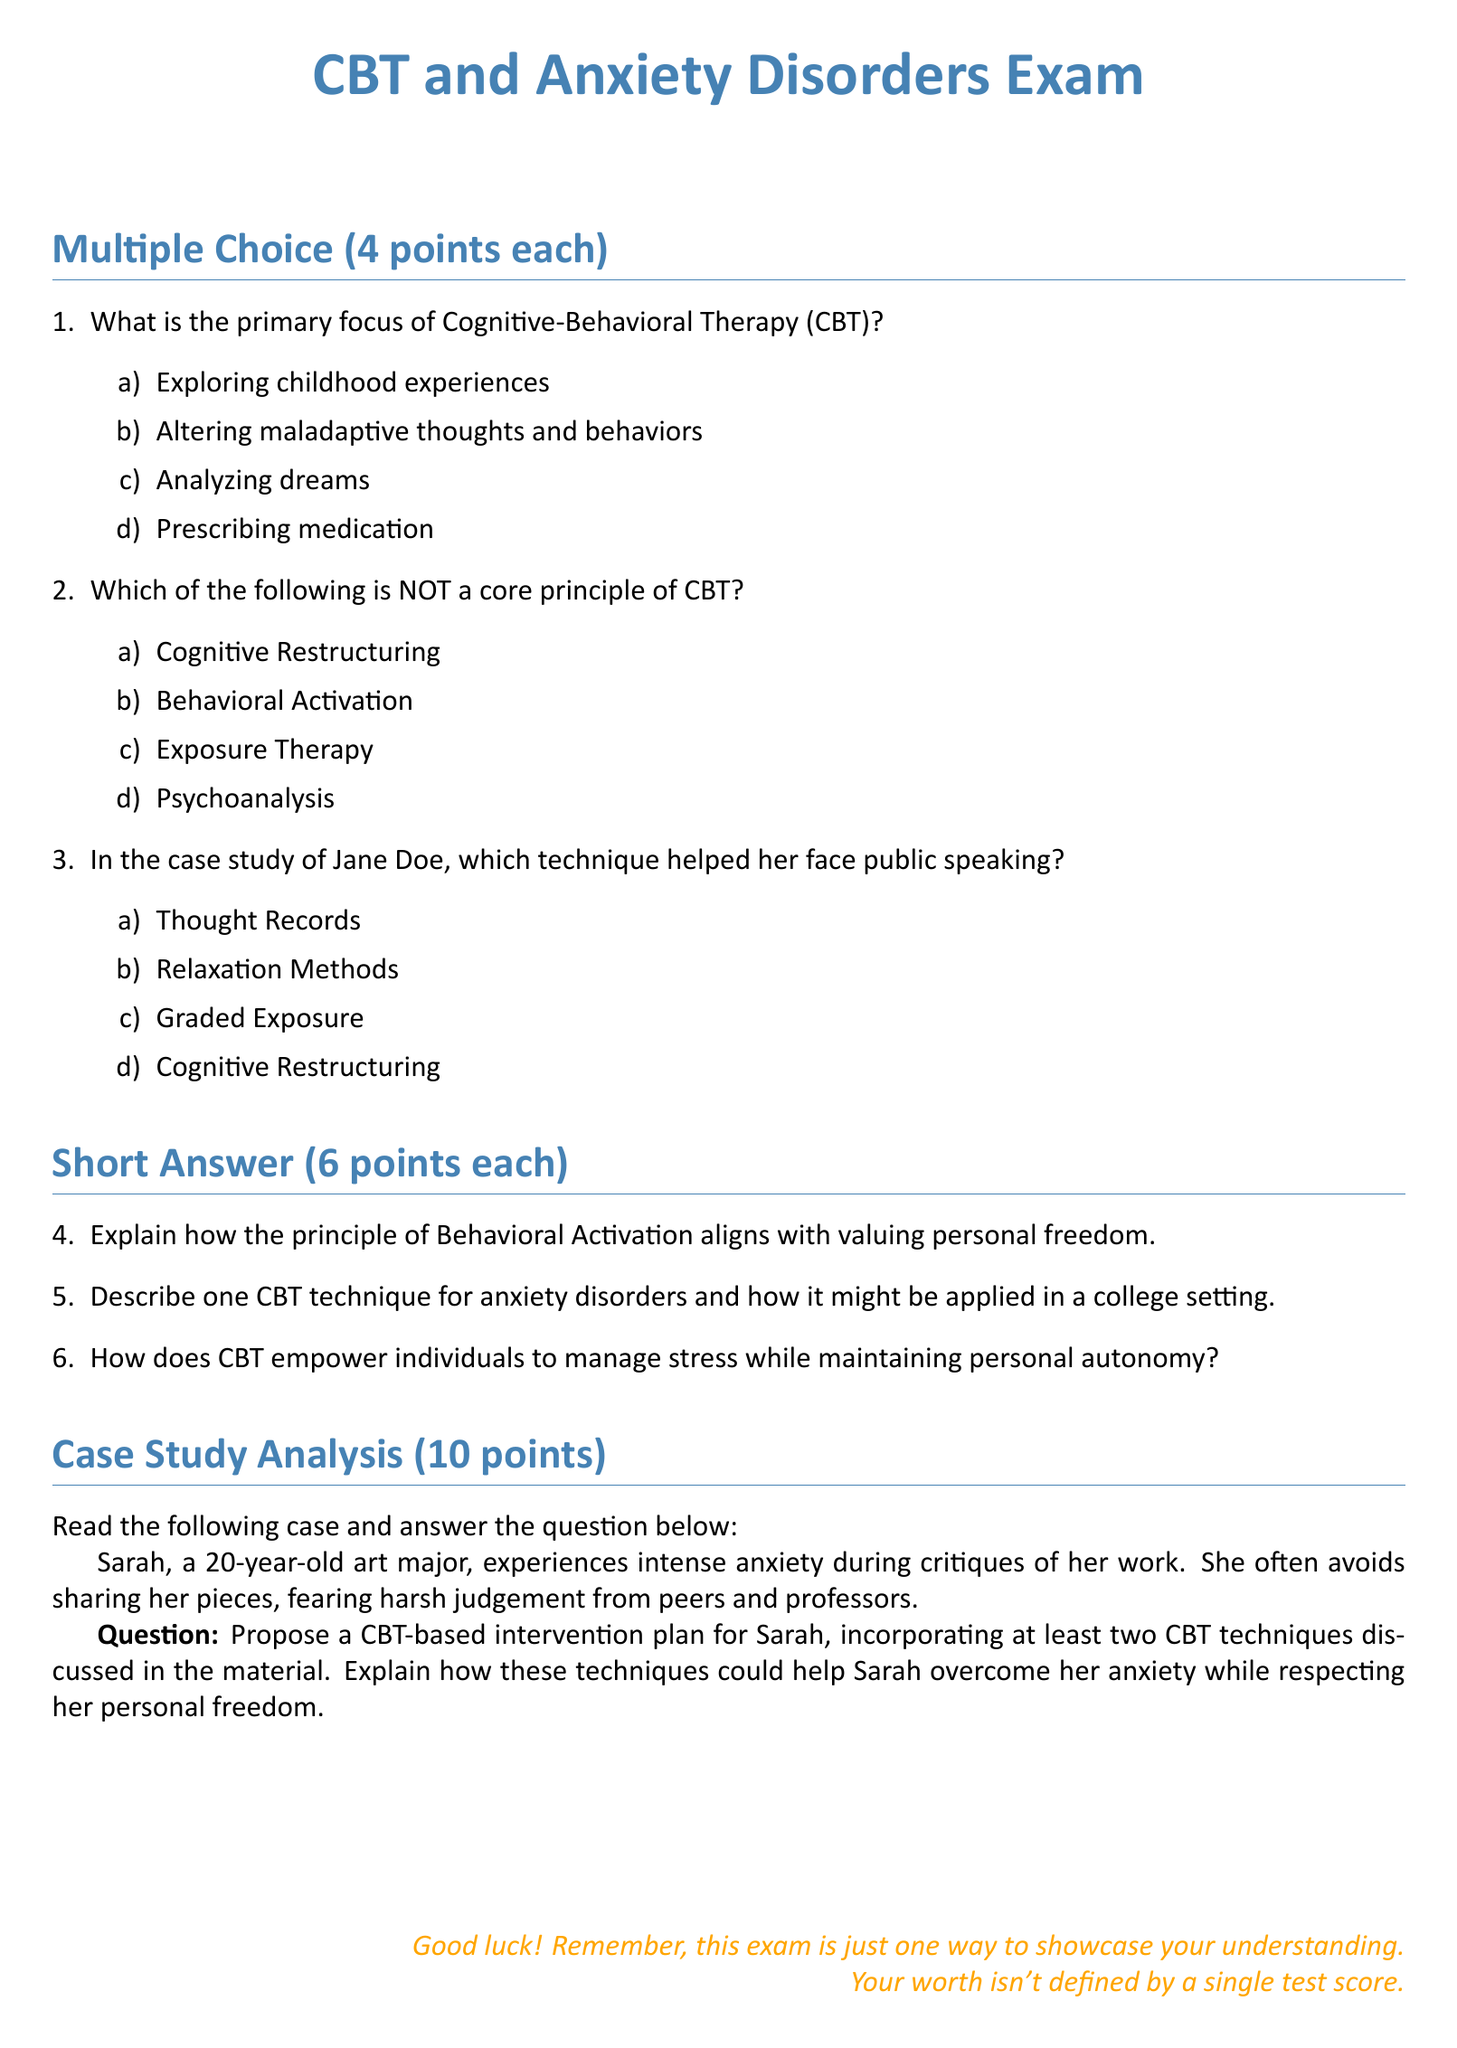What is the title of the exam? The title of the exam is located at the beginning of the document and is presented in large font.
Answer: CBT and Anxiety Disorders Exam What is the maximum score for each multiple-choice question? Each multiple-choice question awards a certain number of points, specified in the section heading.
Answer: 4 points Which technique helped Jane Doe face public speaking? The document provides options for multiple-choice questions, one of which is relevant to Jane's case study.
Answer: Graded Exposure How many points is each short answer question worth? The short answer questions in the exam have a value assigned to them, stated in the section heading.
Answer: 6 points What is one of the core principles of CBT that is NOT listed? The options listed in the multiple-choice questions include one that is not a core principle of CBT.
Answer: Psychoanalysis Which major does Sarah, the subject of a case study, study? Sarah's major is mentioned in the case study section, providing context for her anxiety.
Answer: Art major How many CBT techniques must be incorporated in Sarah's intervention plan? The requirements for the case study analysis specify the number of techniques needed in the intervention plan.
Answer: At least two What color is used for the main title of the exam? The title is styled in a specific color as defined in the document.
Answer: Maincolor What should students remember about the exam according to the conclusion? The conclusion includes a reminder for students about the purpose of the exam and their worth.
Answer: Your worth isn't defined by a single test score 